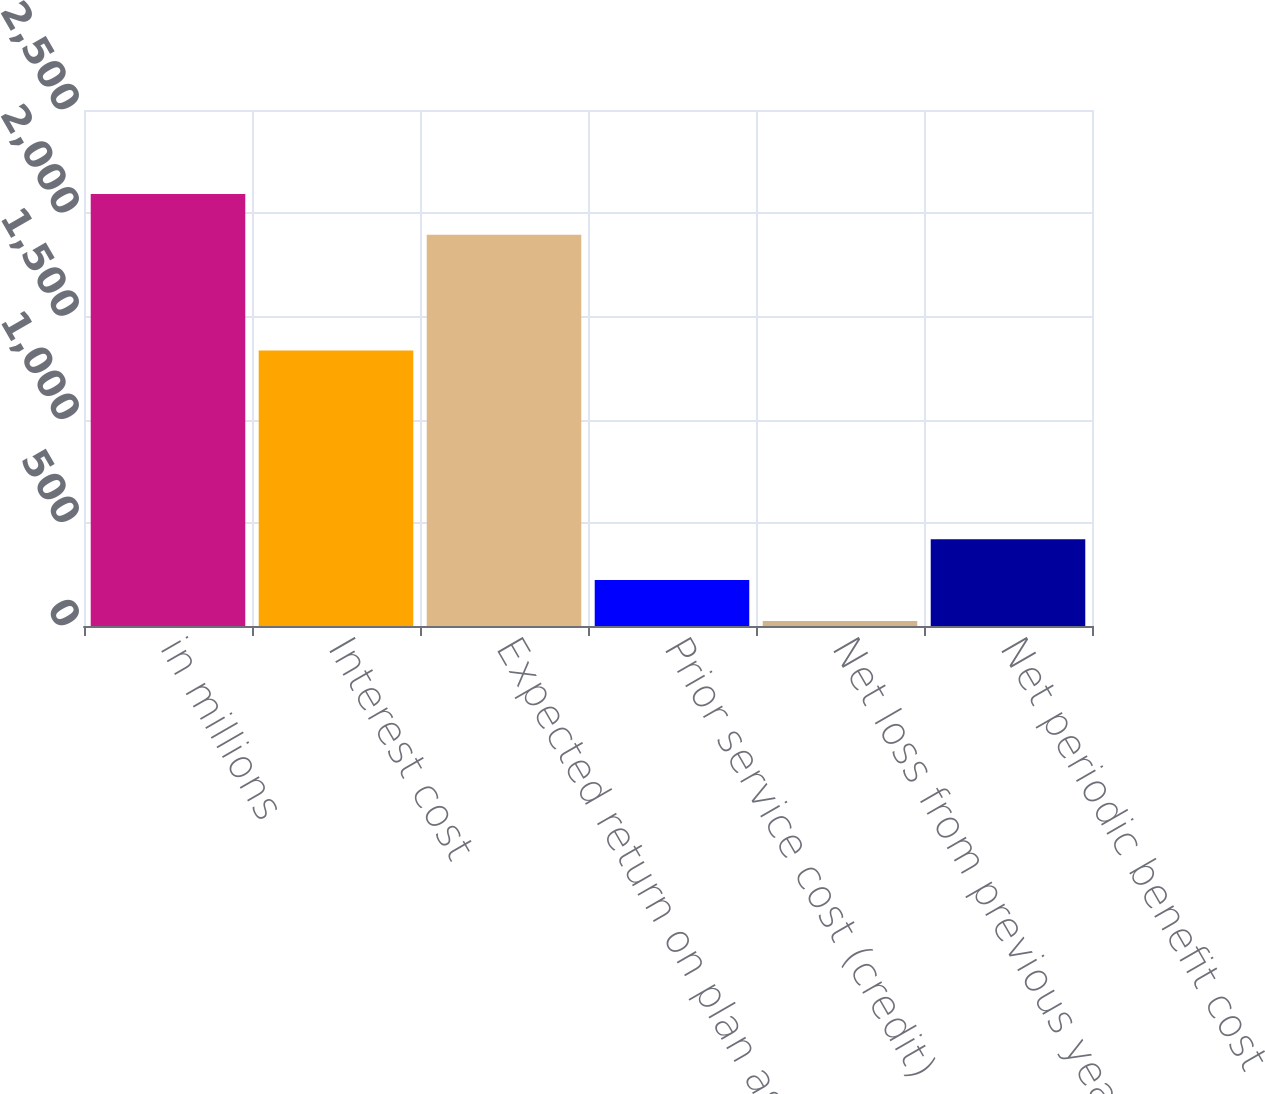Convert chart to OTSL. <chart><loc_0><loc_0><loc_500><loc_500><bar_chart><fcel>in millions<fcel>Interest cost<fcel>Expected return on plan assets<fcel>Prior service cost (credit)<fcel>Net loss from previous years<fcel>Net periodic benefit cost<nl><fcel>2093.4<fcel>1335<fcel>1895<fcel>222.4<fcel>24<fcel>420.8<nl></chart> 